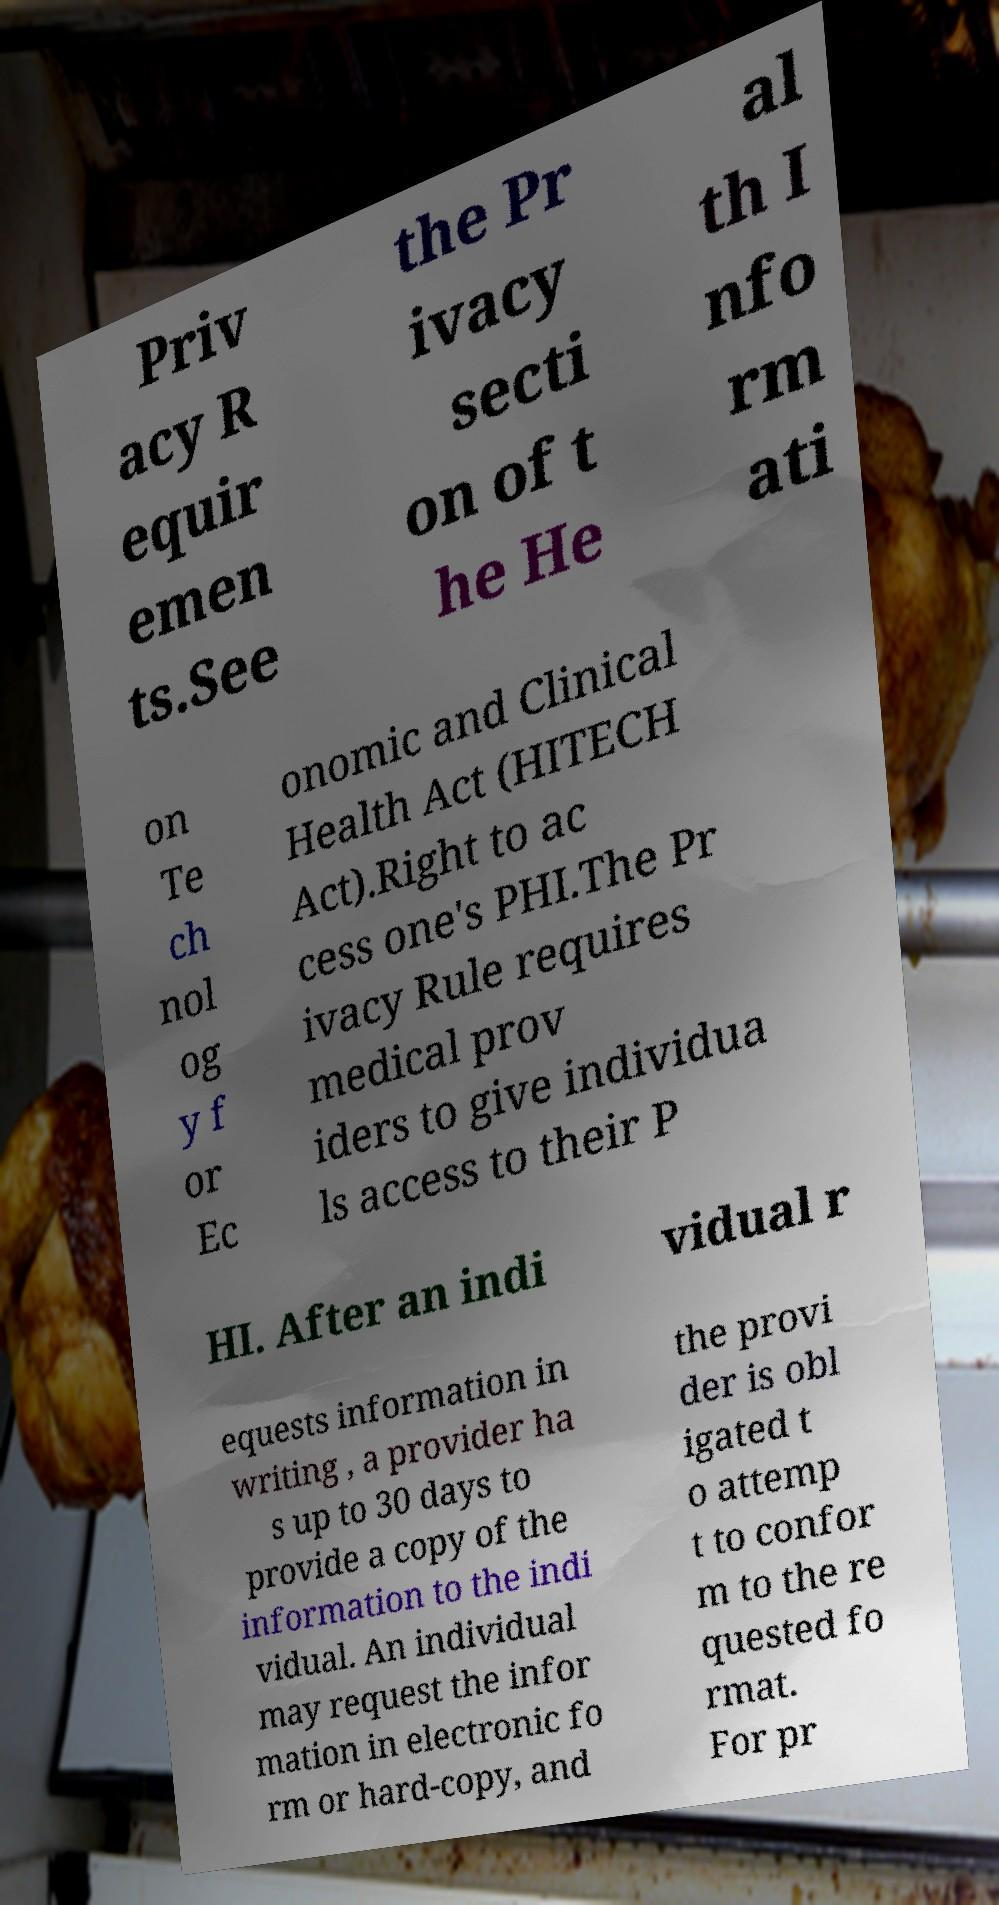Can you accurately transcribe the text from the provided image for me? Priv acy R equir emen ts.See the Pr ivacy secti on of t he He al th I nfo rm ati on Te ch nol og y f or Ec onomic and Clinical Health Act (HITECH Act).Right to ac cess one's PHI.The Pr ivacy Rule requires medical prov iders to give individua ls access to their P HI. After an indi vidual r equests information in writing , a provider ha s up to 30 days to provide a copy of the information to the indi vidual. An individual may request the infor mation in electronic fo rm or hard-copy, and the provi der is obl igated t o attemp t to confor m to the re quested fo rmat. For pr 